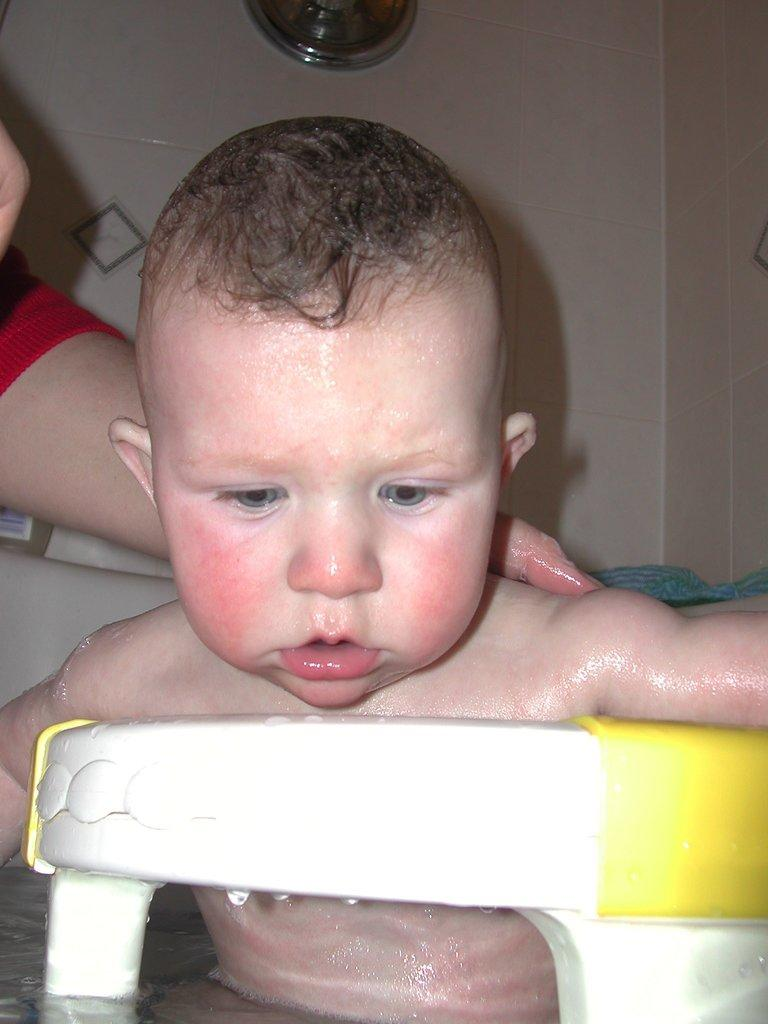What is the main subject in the foreground of the image? There is a baby in the foreground of the image. What is the baby placed in? The baby is in a white color object. What is the nature of the baby's surroundings? The baby is in the water. Whose hand can be seen in the image? There is a person's hand visible in the image. What can be seen in the background of the image? There is a wall in the background of the image. What type of toy is the baby playing with in the image? There is no toy visible in the image; the baby is in the water and surrounded by a white object. 